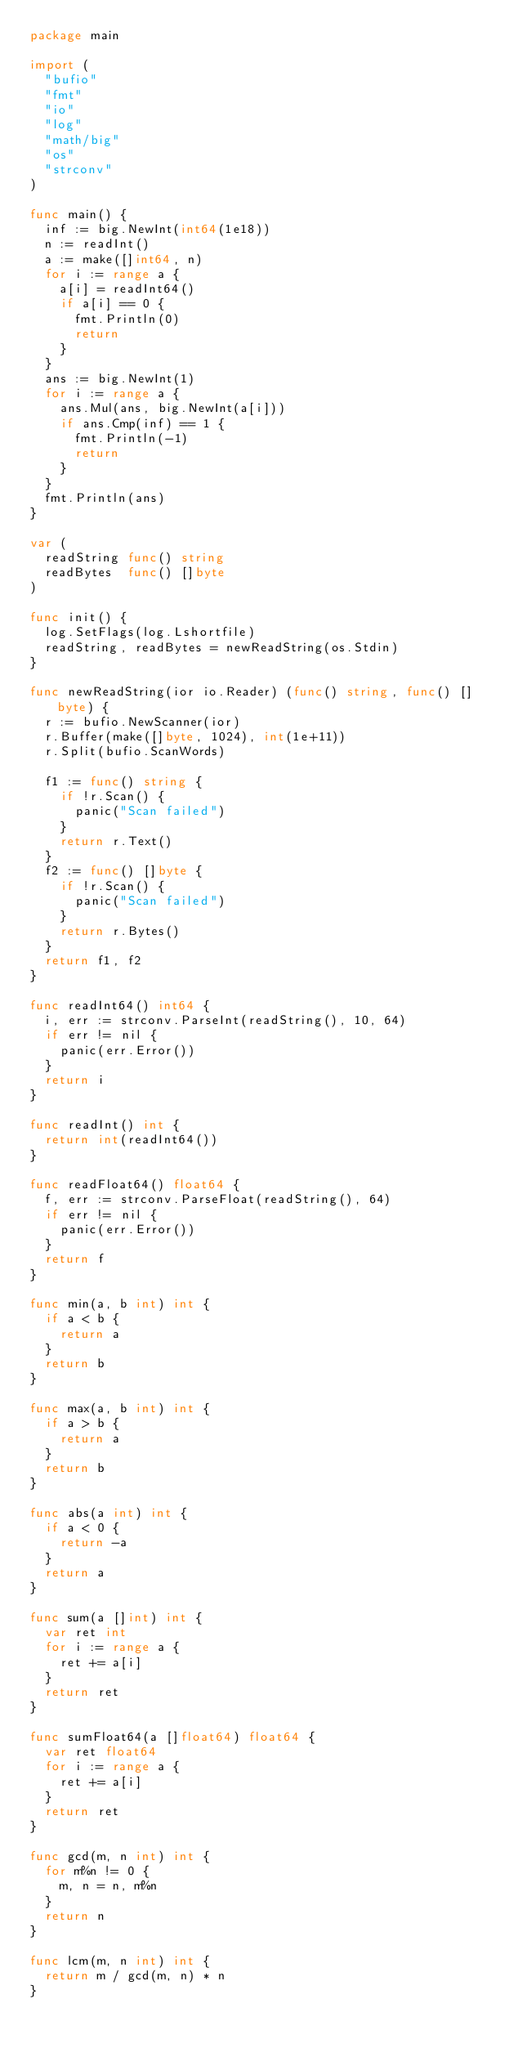<code> <loc_0><loc_0><loc_500><loc_500><_Go_>package main

import (
	"bufio"
	"fmt"
	"io"
	"log"
	"math/big"
	"os"
	"strconv"
)

func main() {
	inf := big.NewInt(int64(1e18))
	n := readInt()
	a := make([]int64, n)
	for i := range a {
		a[i] = readInt64()
		if a[i] == 0 {
			fmt.Println(0)
			return
		}
	}
	ans := big.NewInt(1)
	for i := range a {
		ans.Mul(ans, big.NewInt(a[i]))
		if ans.Cmp(inf) == 1 {
			fmt.Println(-1)
			return
		}
	}
	fmt.Println(ans)
}

var (
	readString func() string
	readBytes  func() []byte
)

func init() {
	log.SetFlags(log.Lshortfile)
	readString, readBytes = newReadString(os.Stdin)
}

func newReadString(ior io.Reader) (func() string, func() []byte) {
	r := bufio.NewScanner(ior)
	r.Buffer(make([]byte, 1024), int(1e+11))
	r.Split(bufio.ScanWords)

	f1 := func() string {
		if !r.Scan() {
			panic("Scan failed")
		}
		return r.Text()
	}
	f2 := func() []byte {
		if !r.Scan() {
			panic("Scan failed")
		}
		return r.Bytes()
	}
	return f1, f2
}

func readInt64() int64 {
	i, err := strconv.ParseInt(readString(), 10, 64)
	if err != nil {
		panic(err.Error())
	}
	return i
}

func readInt() int {
	return int(readInt64())
}

func readFloat64() float64 {
	f, err := strconv.ParseFloat(readString(), 64)
	if err != nil {
		panic(err.Error())
	}
	return f
}

func min(a, b int) int {
	if a < b {
		return a
	}
	return b
}

func max(a, b int) int {
	if a > b {
		return a
	}
	return b
}

func abs(a int) int {
	if a < 0 {
		return -a
	}
	return a
}

func sum(a []int) int {
	var ret int
	for i := range a {
		ret += a[i]
	}
	return ret
}

func sumFloat64(a []float64) float64 {
	var ret float64
	for i := range a {
		ret += a[i]
	}
	return ret
}

func gcd(m, n int) int {
	for m%n != 0 {
		m, n = n, m%n
	}
	return n
}

func lcm(m, n int) int {
	return m / gcd(m, n) * n
}
</code> 